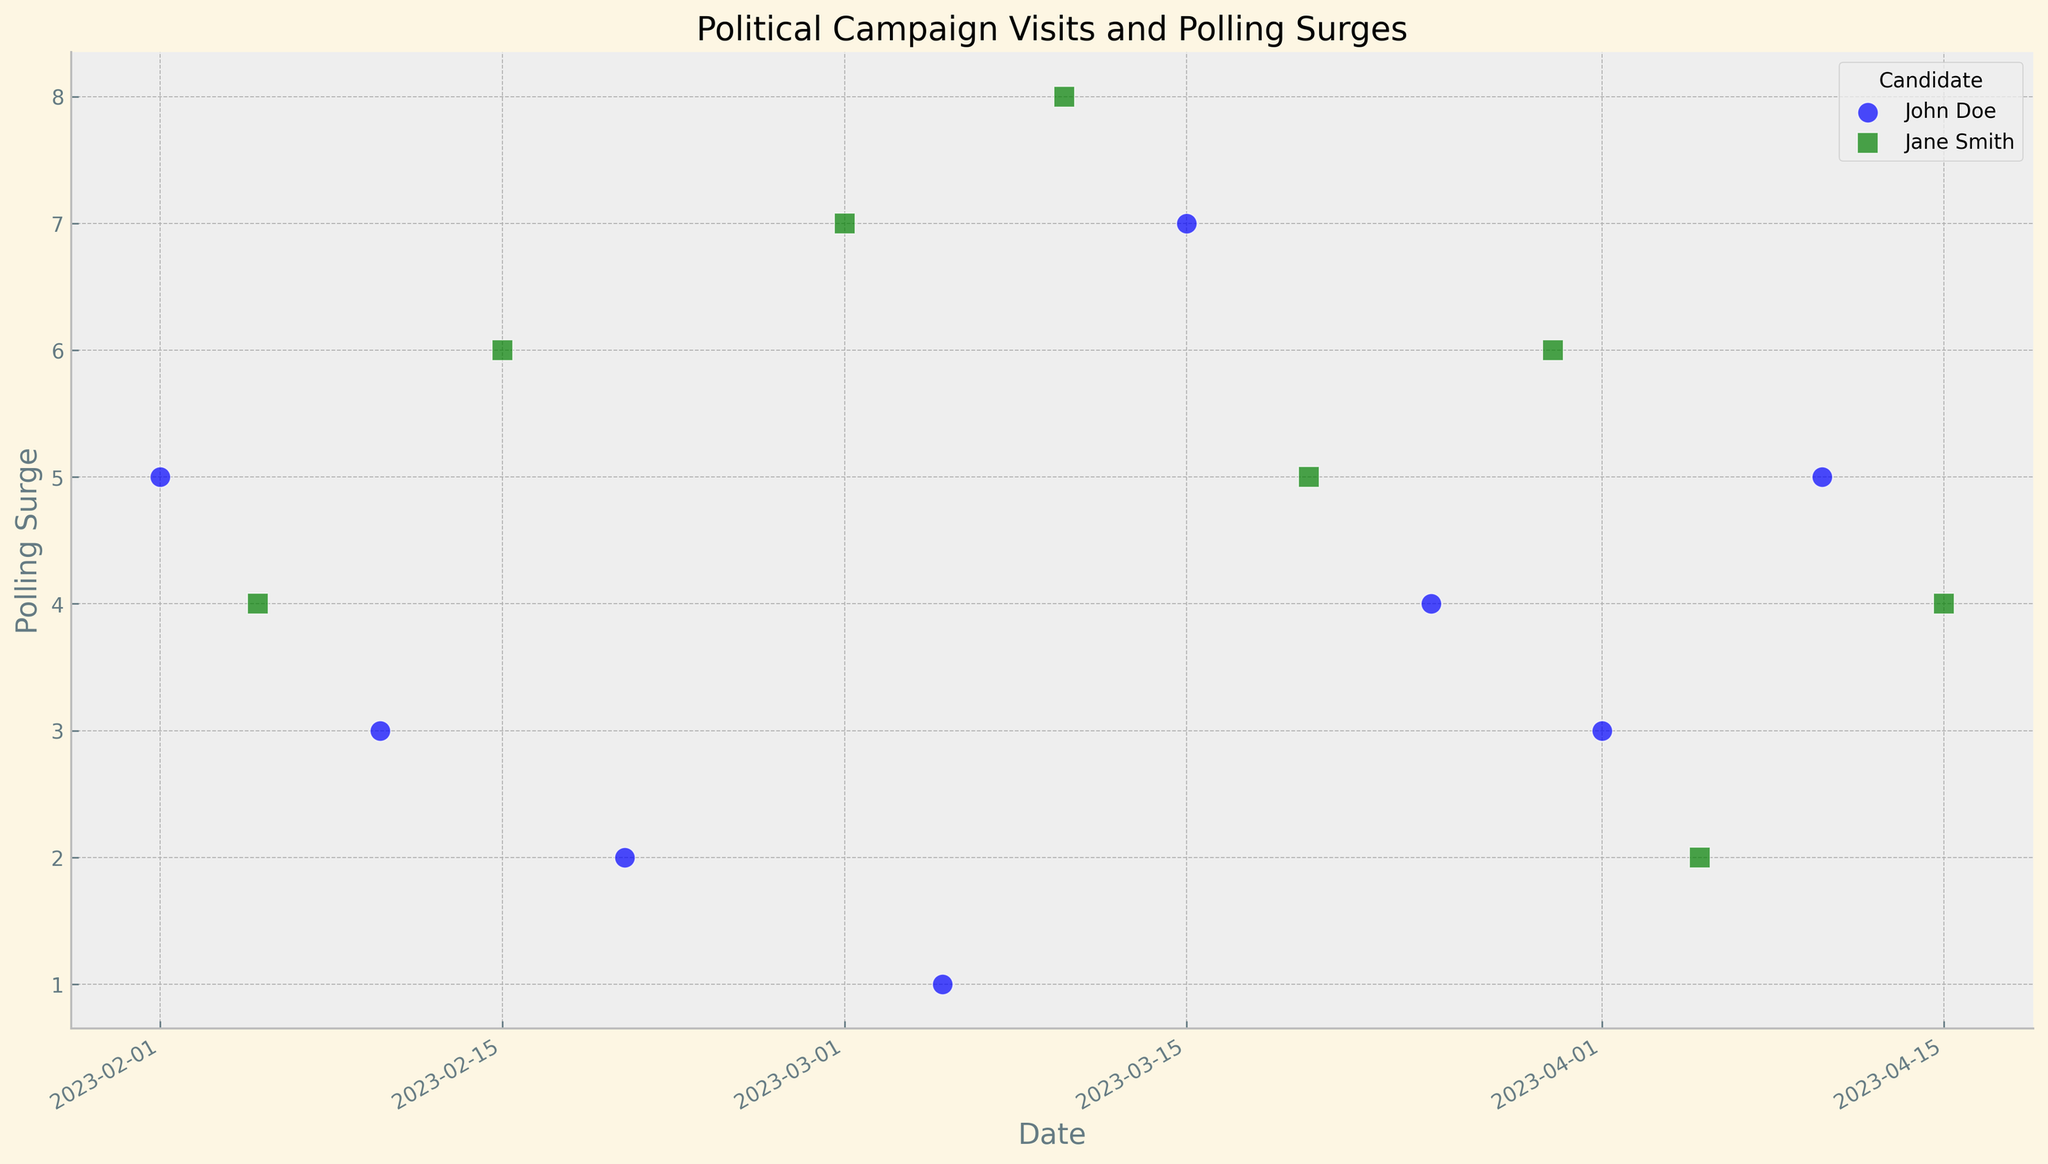What's the highest polling surge recorded for John Doe and when did it occur? The highest polling surge for John Doe can be identified by looking at his data points which are marked in blue and represented by 'o'. The highest value among these points is 7, and it occurred on 2023-03-15 in Colorado Springs.
Answer: 7 on 2023-03-15 Which candidate had a greater overall impact on polling surges in February? To determine this, we sum up the polling surges for both candidates in February. For John Doe, these are 5 (Iowa City) + 3 (Ames) + 2 (Waterloo) = 10. For Jane Smith, these are 4 (Des Moines) + 6 (Cedar Rapids) = 10. Thus, both candidates had an equal impact.
Answer: Both equal with 10 How did Jane Smith's campaign visit to Boulder on 2023-03-01 impact her polling numbers? By looking at the green squares representing Jane Smith, her visit on 2023-03-01 in Boulder led to a polling surge of 7.
Answer: 7 Compare the trends in polling surges for both candidates in March, and who performed better overall? Summing up the polling surges in March for John Doe: 1 (Denver) + 7 (Colorado Springs) + 4 (Albuquerque) = 12. For Jane Smith: 7 (Boulder) + 8 (Fort Collins) + 5 (Pueblo) + 6 (Santa Fe) = 26. Jane Smith had a higher total surge, thus she performed better.
Answer: Jane Smith with 26 What is the average polling surge for Jane Smith across all campaign stops? Adding up all of Jane Smith's polling surges: 4 + 6 + 7 + 8 + 5 + 6 + 2 + 4 = 42. Jane Smith has visited 8 locations, so the average is 42 / 8 = 5.25.
Answer: 5.25 Which location had the lowest polling surge recorded and for which candidate? Observe the data points for the lowest value. A polling surge of 1, which is the lowest, was recorded for John Doe on 2023-03-05 in Denver.
Answer: Denver for John Doe Are there any dates where both candidates had campaign stops, and how did their polling surges compare on those dates? By inspecting the dates, we see that no dates are shared by both candidates. Thus, there are no direct comparisons on the same days.
Answer: No shared dates Compare the polling surge patterns between John Doe and Jane Smith in the first and last months recorded. Who had the most consistent surges between February and April? For February, John Doe has surges of 5, 3, 2 (Total=10, Average=3.33) and Jane Smith has 4, 6 (Total=10, Average=5). For April, John Doe has 3, 5 (Total=8, Average=4) and Jane Smith has 2, 4 (Total=6, Average=3). John Doe maintained a higher average in April compared to February, showing improved consistency.
Answer: John Doe 